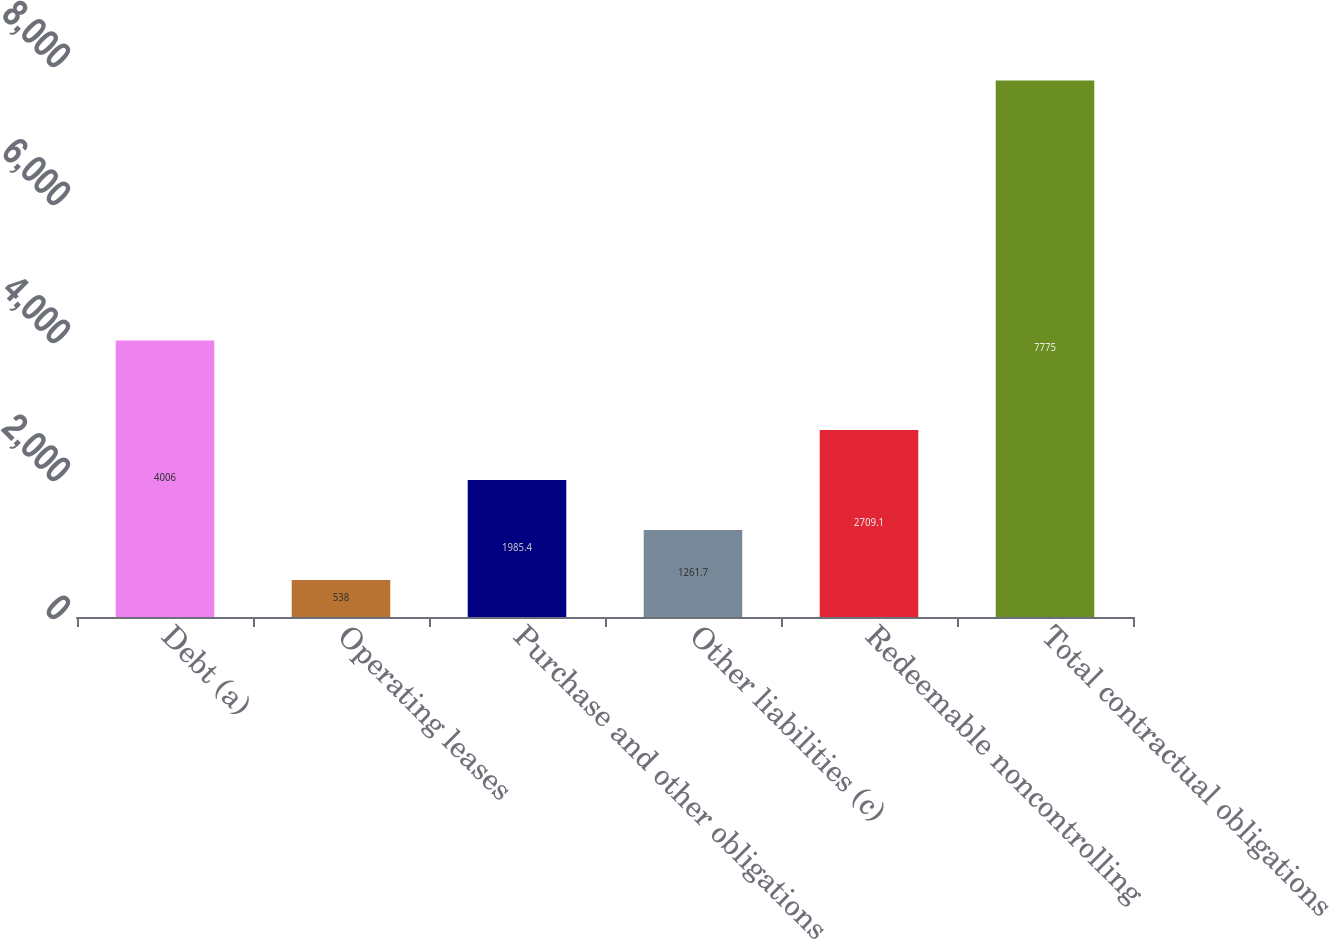Convert chart to OTSL. <chart><loc_0><loc_0><loc_500><loc_500><bar_chart><fcel>Debt (a)<fcel>Operating leases<fcel>Purchase and other obligations<fcel>Other liabilities (c)<fcel>Redeemable noncontrolling<fcel>Total contractual obligations<nl><fcel>4006<fcel>538<fcel>1985.4<fcel>1261.7<fcel>2709.1<fcel>7775<nl></chart> 